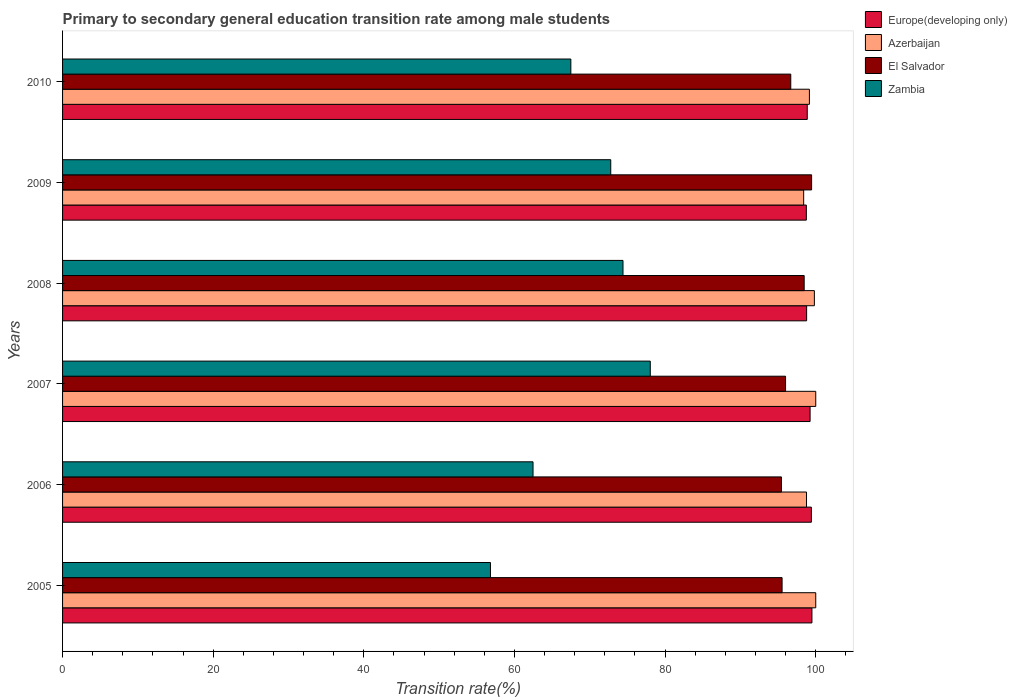How many different coloured bars are there?
Your answer should be compact. 4. How many groups of bars are there?
Provide a short and direct response. 6. Are the number of bars per tick equal to the number of legend labels?
Provide a succinct answer. Yes. Are the number of bars on each tick of the Y-axis equal?
Offer a terse response. Yes. How many bars are there on the 4th tick from the bottom?
Your answer should be very brief. 4. In how many cases, is the number of bars for a given year not equal to the number of legend labels?
Ensure brevity in your answer.  0. What is the transition rate in Europe(developing only) in 2008?
Offer a very short reply. 98.79. Across all years, what is the maximum transition rate in El Salvador?
Provide a short and direct response. 99.45. Across all years, what is the minimum transition rate in Zambia?
Offer a very short reply. 56.81. What is the total transition rate in El Salvador in the graph?
Ensure brevity in your answer.  581.56. What is the difference between the transition rate in Europe(developing only) in 2007 and that in 2010?
Keep it short and to the point. 0.38. What is the difference between the transition rate in Azerbaijan in 2006 and the transition rate in Zambia in 2008?
Provide a succinct answer. 24.37. What is the average transition rate in Europe(developing only) per year?
Make the answer very short. 99.09. In the year 2005, what is the difference between the transition rate in El Salvador and transition rate in Azerbaijan?
Offer a very short reply. -4.47. What is the ratio of the transition rate in Europe(developing only) in 2005 to that in 2007?
Offer a terse response. 1. What is the difference between the highest and the second highest transition rate in El Salvador?
Offer a very short reply. 0.99. What is the difference between the highest and the lowest transition rate in Azerbaijan?
Offer a very short reply. 1.6. In how many years, is the transition rate in El Salvador greater than the average transition rate in El Salvador taken over all years?
Your answer should be very brief. 2. Is the sum of the transition rate in Zambia in 2007 and 2009 greater than the maximum transition rate in Azerbaijan across all years?
Provide a short and direct response. Yes. What does the 3rd bar from the top in 2008 represents?
Offer a very short reply. Azerbaijan. What does the 2nd bar from the bottom in 2009 represents?
Provide a short and direct response. Azerbaijan. Is it the case that in every year, the sum of the transition rate in Zambia and transition rate in El Salvador is greater than the transition rate in Azerbaijan?
Offer a terse response. Yes. How many bars are there?
Ensure brevity in your answer.  24. Are all the bars in the graph horizontal?
Offer a very short reply. Yes. How many years are there in the graph?
Your answer should be compact. 6. How many legend labels are there?
Offer a very short reply. 4. What is the title of the graph?
Your response must be concise. Primary to secondary general education transition rate among male students. Does "Eritrea" appear as one of the legend labels in the graph?
Provide a short and direct response. No. What is the label or title of the X-axis?
Provide a succinct answer. Transition rate(%). What is the Transition rate(%) in Europe(developing only) in 2005?
Provide a succinct answer. 99.49. What is the Transition rate(%) in Azerbaijan in 2005?
Ensure brevity in your answer.  100. What is the Transition rate(%) in El Salvador in 2005?
Keep it short and to the point. 95.53. What is the Transition rate(%) in Zambia in 2005?
Offer a terse response. 56.81. What is the Transition rate(%) in Europe(developing only) in 2006?
Provide a succinct answer. 99.42. What is the Transition rate(%) in Azerbaijan in 2006?
Your response must be concise. 98.77. What is the Transition rate(%) in El Salvador in 2006?
Provide a short and direct response. 95.45. What is the Transition rate(%) of Zambia in 2006?
Give a very brief answer. 62.46. What is the Transition rate(%) in Europe(developing only) in 2007?
Give a very brief answer. 99.25. What is the Transition rate(%) in El Salvador in 2007?
Offer a very short reply. 95.99. What is the Transition rate(%) in Zambia in 2007?
Give a very brief answer. 78.03. What is the Transition rate(%) in Europe(developing only) in 2008?
Provide a succinct answer. 98.79. What is the Transition rate(%) in Azerbaijan in 2008?
Give a very brief answer. 99.82. What is the Transition rate(%) of El Salvador in 2008?
Ensure brevity in your answer.  98.46. What is the Transition rate(%) of Zambia in 2008?
Ensure brevity in your answer.  74.41. What is the Transition rate(%) of Europe(developing only) in 2009?
Provide a succinct answer. 98.75. What is the Transition rate(%) of Azerbaijan in 2009?
Provide a succinct answer. 98.4. What is the Transition rate(%) in El Salvador in 2009?
Make the answer very short. 99.45. What is the Transition rate(%) in Zambia in 2009?
Give a very brief answer. 72.78. What is the Transition rate(%) of Europe(developing only) in 2010?
Your response must be concise. 98.87. What is the Transition rate(%) in Azerbaijan in 2010?
Offer a very short reply. 99.16. What is the Transition rate(%) of El Salvador in 2010?
Your response must be concise. 96.68. What is the Transition rate(%) in Zambia in 2010?
Make the answer very short. 67.48. Across all years, what is the maximum Transition rate(%) of Europe(developing only)?
Provide a succinct answer. 99.49. Across all years, what is the maximum Transition rate(%) in Azerbaijan?
Keep it short and to the point. 100. Across all years, what is the maximum Transition rate(%) in El Salvador?
Give a very brief answer. 99.45. Across all years, what is the maximum Transition rate(%) in Zambia?
Ensure brevity in your answer.  78.03. Across all years, what is the minimum Transition rate(%) in Europe(developing only)?
Your response must be concise. 98.75. Across all years, what is the minimum Transition rate(%) of Azerbaijan?
Offer a very short reply. 98.4. Across all years, what is the minimum Transition rate(%) in El Salvador?
Offer a terse response. 95.45. Across all years, what is the minimum Transition rate(%) in Zambia?
Your response must be concise. 56.81. What is the total Transition rate(%) in Europe(developing only) in the graph?
Your answer should be very brief. 594.57. What is the total Transition rate(%) in Azerbaijan in the graph?
Provide a succinct answer. 596.14. What is the total Transition rate(%) of El Salvador in the graph?
Ensure brevity in your answer.  581.56. What is the total Transition rate(%) in Zambia in the graph?
Your answer should be compact. 411.98. What is the difference between the Transition rate(%) in Europe(developing only) in 2005 and that in 2006?
Keep it short and to the point. 0.08. What is the difference between the Transition rate(%) of Azerbaijan in 2005 and that in 2006?
Your response must be concise. 1.23. What is the difference between the Transition rate(%) of El Salvador in 2005 and that in 2006?
Make the answer very short. 0.08. What is the difference between the Transition rate(%) in Zambia in 2005 and that in 2006?
Offer a very short reply. -5.65. What is the difference between the Transition rate(%) of Europe(developing only) in 2005 and that in 2007?
Give a very brief answer. 0.24. What is the difference between the Transition rate(%) in El Salvador in 2005 and that in 2007?
Your answer should be very brief. -0.46. What is the difference between the Transition rate(%) in Zambia in 2005 and that in 2007?
Your response must be concise. -21.22. What is the difference between the Transition rate(%) in Europe(developing only) in 2005 and that in 2008?
Keep it short and to the point. 0.7. What is the difference between the Transition rate(%) in Azerbaijan in 2005 and that in 2008?
Offer a terse response. 0.18. What is the difference between the Transition rate(%) of El Salvador in 2005 and that in 2008?
Your answer should be very brief. -2.93. What is the difference between the Transition rate(%) in Zambia in 2005 and that in 2008?
Provide a short and direct response. -17.6. What is the difference between the Transition rate(%) of Europe(developing only) in 2005 and that in 2009?
Give a very brief answer. 0.74. What is the difference between the Transition rate(%) in Azerbaijan in 2005 and that in 2009?
Your response must be concise. 1.6. What is the difference between the Transition rate(%) in El Salvador in 2005 and that in 2009?
Offer a terse response. -3.92. What is the difference between the Transition rate(%) of Zambia in 2005 and that in 2009?
Your answer should be compact. -15.97. What is the difference between the Transition rate(%) in Europe(developing only) in 2005 and that in 2010?
Offer a terse response. 0.62. What is the difference between the Transition rate(%) of Azerbaijan in 2005 and that in 2010?
Give a very brief answer. 0.84. What is the difference between the Transition rate(%) in El Salvador in 2005 and that in 2010?
Your response must be concise. -1.15. What is the difference between the Transition rate(%) of Zambia in 2005 and that in 2010?
Your answer should be compact. -10.67. What is the difference between the Transition rate(%) in Europe(developing only) in 2006 and that in 2007?
Provide a short and direct response. 0.17. What is the difference between the Transition rate(%) in Azerbaijan in 2006 and that in 2007?
Make the answer very short. -1.23. What is the difference between the Transition rate(%) of El Salvador in 2006 and that in 2007?
Provide a succinct answer. -0.55. What is the difference between the Transition rate(%) in Zambia in 2006 and that in 2007?
Your answer should be compact. -15.57. What is the difference between the Transition rate(%) in Europe(developing only) in 2006 and that in 2008?
Offer a very short reply. 0.63. What is the difference between the Transition rate(%) of Azerbaijan in 2006 and that in 2008?
Offer a very short reply. -1.04. What is the difference between the Transition rate(%) in El Salvador in 2006 and that in 2008?
Offer a very short reply. -3.02. What is the difference between the Transition rate(%) in Zambia in 2006 and that in 2008?
Provide a succinct answer. -11.94. What is the difference between the Transition rate(%) of Europe(developing only) in 2006 and that in 2009?
Make the answer very short. 0.67. What is the difference between the Transition rate(%) in Azerbaijan in 2006 and that in 2009?
Your answer should be very brief. 0.38. What is the difference between the Transition rate(%) in El Salvador in 2006 and that in 2009?
Ensure brevity in your answer.  -4. What is the difference between the Transition rate(%) of Zambia in 2006 and that in 2009?
Your answer should be compact. -10.32. What is the difference between the Transition rate(%) in Europe(developing only) in 2006 and that in 2010?
Provide a short and direct response. 0.54. What is the difference between the Transition rate(%) in Azerbaijan in 2006 and that in 2010?
Ensure brevity in your answer.  -0.38. What is the difference between the Transition rate(%) in El Salvador in 2006 and that in 2010?
Provide a short and direct response. -1.24. What is the difference between the Transition rate(%) in Zambia in 2006 and that in 2010?
Provide a succinct answer. -5.02. What is the difference between the Transition rate(%) of Europe(developing only) in 2007 and that in 2008?
Offer a very short reply. 0.46. What is the difference between the Transition rate(%) in Azerbaijan in 2007 and that in 2008?
Offer a very short reply. 0.18. What is the difference between the Transition rate(%) in El Salvador in 2007 and that in 2008?
Provide a short and direct response. -2.47. What is the difference between the Transition rate(%) in Zambia in 2007 and that in 2008?
Offer a very short reply. 3.62. What is the difference between the Transition rate(%) of Europe(developing only) in 2007 and that in 2009?
Your answer should be compact. 0.5. What is the difference between the Transition rate(%) of Azerbaijan in 2007 and that in 2009?
Keep it short and to the point. 1.6. What is the difference between the Transition rate(%) of El Salvador in 2007 and that in 2009?
Your answer should be very brief. -3.46. What is the difference between the Transition rate(%) of Zambia in 2007 and that in 2009?
Give a very brief answer. 5.25. What is the difference between the Transition rate(%) in Europe(developing only) in 2007 and that in 2010?
Keep it short and to the point. 0.38. What is the difference between the Transition rate(%) of Azerbaijan in 2007 and that in 2010?
Offer a very short reply. 0.84. What is the difference between the Transition rate(%) of El Salvador in 2007 and that in 2010?
Keep it short and to the point. -0.69. What is the difference between the Transition rate(%) in Zambia in 2007 and that in 2010?
Offer a very short reply. 10.55. What is the difference between the Transition rate(%) of Europe(developing only) in 2008 and that in 2009?
Provide a succinct answer. 0.04. What is the difference between the Transition rate(%) of Azerbaijan in 2008 and that in 2009?
Keep it short and to the point. 1.42. What is the difference between the Transition rate(%) of El Salvador in 2008 and that in 2009?
Your answer should be compact. -0.99. What is the difference between the Transition rate(%) of Zambia in 2008 and that in 2009?
Provide a succinct answer. 1.63. What is the difference between the Transition rate(%) in Europe(developing only) in 2008 and that in 2010?
Offer a very short reply. -0.08. What is the difference between the Transition rate(%) in Azerbaijan in 2008 and that in 2010?
Provide a succinct answer. 0.66. What is the difference between the Transition rate(%) of El Salvador in 2008 and that in 2010?
Your answer should be very brief. 1.78. What is the difference between the Transition rate(%) of Zambia in 2008 and that in 2010?
Offer a very short reply. 6.92. What is the difference between the Transition rate(%) in Europe(developing only) in 2009 and that in 2010?
Your response must be concise. -0.12. What is the difference between the Transition rate(%) of Azerbaijan in 2009 and that in 2010?
Provide a short and direct response. -0.76. What is the difference between the Transition rate(%) of El Salvador in 2009 and that in 2010?
Your answer should be compact. 2.77. What is the difference between the Transition rate(%) of Zambia in 2009 and that in 2010?
Offer a terse response. 5.3. What is the difference between the Transition rate(%) of Europe(developing only) in 2005 and the Transition rate(%) of Azerbaijan in 2006?
Make the answer very short. 0.72. What is the difference between the Transition rate(%) in Europe(developing only) in 2005 and the Transition rate(%) in El Salvador in 2006?
Your answer should be very brief. 4.05. What is the difference between the Transition rate(%) of Europe(developing only) in 2005 and the Transition rate(%) of Zambia in 2006?
Your answer should be very brief. 37.03. What is the difference between the Transition rate(%) of Azerbaijan in 2005 and the Transition rate(%) of El Salvador in 2006?
Keep it short and to the point. 4.55. What is the difference between the Transition rate(%) in Azerbaijan in 2005 and the Transition rate(%) in Zambia in 2006?
Ensure brevity in your answer.  37.54. What is the difference between the Transition rate(%) of El Salvador in 2005 and the Transition rate(%) of Zambia in 2006?
Keep it short and to the point. 33.07. What is the difference between the Transition rate(%) of Europe(developing only) in 2005 and the Transition rate(%) of Azerbaijan in 2007?
Your answer should be very brief. -0.51. What is the difference between the Transition rate(%) in Europe(developing only) in 2005 and the Transition rate(%) in El Salvador in 2007?
Give a very brief answer. 3.5. What is the difference between the Transition rate(%) in Europe(developing only) in 2005 and the Transition rate(%) in Zambia in 2007?
Offer a terse response. 21.46. What is the difference between the Transition rate(%) in Azerbaijan in 2005 and the Transition rate(%) in El Salvador in 2007?
Your answer should be very brief. 4.01. What is the difference between the Transition rate(%) in Azerbaijan in 2005 and the Transition rate(%) in Zambia in 2007?
Your answer should be very brief. 21.97. What is the difference between the Transition rate(%) of El Salvador in 2005 and the Transition rate(%) of Zambia in 2007?
Provide a succinct answer. 17.5. What is the difference between the Transition rate(%) of Europe(developing only) in 2005 and the Transition rate(%) of Azerbaijan in 2008?
Your answer should be very brief. -0.33. What is the difference between the Transition rate(%) of Europe(developing only) in 2005 and the Transition rate(%) of El Salvador in 2008?
Provide a short and direct response. 1.03. What is the difference between the Transition rate(%) in Europe(developing only) in 2005 and the Transition rate(%) in Zambia in 2008?
Your response must be concise. 25.09. What is the difference between the Transition rate(%) of Azerbaijan in 2005 and the Transition rate(%) of El Salvador in 2008?
Provide a succinct answer. 1.54. What is the difference between the Transition rate(%) in Azerbaijan in 2005 and the Transition rate(%) in Zambia in 2008?
Make the answer very short. 25.59. What is the difference between the Transition rate(%) of El Salvador in 2005 and the Transition rate(%) of Zambia in 2008?
Your answer should be compact. 21.12. What is the difference between the Transition rate(%) in Europe(developing only) in 2005 and the Transition rate(%) in Azerbaijan in 2009?
Ensure brevity in your answer.  1.1. What is the difference between the Transition rate(%) in Europe(developing only) in 2005 and the Transition rate(%) in El Salvador in 2009?
Offer a terse response. 0.04. What is the difference between the Transition rate(%) in Europe(developing only) in 2005 and the Transition rate(%) in Zambia in 2009?
Make the answer very short. 26.71. What is the difference between the Transition rate(%) of Azerbaijan in 2005 and the Transition rate(%) of El Salvador in 2009?
Keep it short and to the point. 0.55. What is the difference between the Transition rate(%) of Azerbaijan in 2005 and the Transition rate(%) of Zambia in 2009?
Ensure brevity in your answer.  27.22. What is the difference between the Transition rate(%) in El Salvador in 2005 and the Transition rate(%) in Zambia in 2009?
Give a very brief answer. 22.75. What is the difference between the Transition rate(%) in Europe(developing only) in 2005 and the Transition rate(%) in Azerbaijan in 2010?
Give a very brief answer. 0.34. What is the difference between the Transition rate(%) of Europe(developing only) in 2005 and the Transition rate(%) of El Salvador in 2010?
Your answer should be compact. 2.81. What is the difference between the Transition rate(%) in Europe(developing only) in 2005 and the Transition rate(%) in Zambia in 2010?
Your answer should be compact. 32.01. What is the difference between the Transition rate(%) of Azerbaijan in 2005 and the Transition rate(%) of El Salvador in 2010?
Ensure brevity in your answer.  3.32. What is the difference between the Transition rate(%) of Azerbaijan in 2005 and the Transition rate(%) of Zambia in 2010?
Make the answer very short. 32.52. What is the difference between the Transition rate(%) in El Salvador in 2005 and the Transition rate(%) in Zambia in 2010?
Your answer should be very brief. 28.04. What is the difference between the Transition rate(%) of Europe(developing only) in 2006 and the Transition rate(%) of Azerbaijan in 2007?
Provide a succinct answer. -0.58. What is the difference between the Transition rate(%) of Europe(developing only) in 2006 and the Transition rate(%) of El Salvador in 2007?
Provide a short and direct response. 3.43. What is the difference between the Transition rate(%) in Europe(developing only) in 2006 and the Transition rate(%) in Zambia in 2007?
Offer a very short reply. 21.39. What is the difference between the Transition rate(%) of Azerbaijan in 2006 and the Transition rate(%) of El Salvador in 2007?
Keep it short and to the point. 2.78. What is the difference between the Transition rate(%) of Azerbaijan in 2006 and the Transition rate(%) of Zambia in 2007?
Offer a very short reply. 20.74. What is the difference between the Transition rate(%) of El Salvador in 2006 and the Transition rate(%) of Zambia in 2007?
Give a very brief answer. 17.42. What is the difference between the Transition rate(%) in Europe(developing only) in 2006 and the Transition rate(%) in Azerbaijan in 2008?
Make the answer very short. -0.4. What is the difference between the Transition rate(%) of Europe(developing only) in 2006 and the Transition rate(%) of El Salvador in 2008?
Ensure brevity in your answer.  0.96. What is the difference between the Transition rate(%) in Europe(developing only) in 2006 and the Transition rate(%) in Zambia in 2008?
Offer a very short reply. 25.01. What is the difference between the Transition rate(%) in Azerbaijan in 2006 and the Transition rate(%) in El Salvador in 2008?
Keep it short and to the point. 0.31. What is the difference between the Transition rate(%) of Azerbaijan in 2006 and the Transition rate(%) of Zambia in 2008?
Your answer should be very brief. 24.37. What is the difference between the Transition rate(%) of El Salvador in 2006 and the Transition rate(%) of Zambia in 2008?
Make the answer very short. 21.04. What is the difference between the Transition rate(%) in Europe(developing only) in 2006 and the Transition rate(%) in Azerbaijan in 2009?
Offer a very short reply. 1.02. What is the difference between the Transition rate(%) in Europe(developing only) in 2006 and the Transition rate(%) in El Salvador in 2009?
Provide a short and direct response. -0.03. What is the difference between the Transition rate(%) in Europe(developing only) in 2006 and the Transition rate(%) in Zambia in 2009?
Give a very brief answer. 26.64. What is the difference between the Transition rate(%) of Azerbaijan in 2006 and the Transition rate(%) of El Salvador in 2009?
Your answer should be compact. -0.68. What is the difference between the Transition rate(%) in Azerbaijan in 2006 and the Transition rate(%) in Zambia in 2009?
Provide a succinct answer. 25.99. What is the difference between the Transition rate(%) of El Salvador in 2006 and the Transition rate(%) of Zambia in 2009?
Your answer should be compact. 22.66. What is the difference between the Transition rate(%) of Europe(developing only) in 2006 and the Transition rate(%) of Azerbaijan in 2010?
Make the answer very short. 0.26. What is the difference between the Transition rate(%) in Europe(developing only) in 2006 and the Transition rate(%) in El Salvador in 2010?
Make the answer very short. 2.73. What is the difference between the Transition rate(%) of Europe(developing only) in 2006 and the Transition rate(%) of Zambia in 2010?
Make the answer very short. 31.93. What is the difference between the Transition rate(%) of Azerbaijan in 2006 and the Transition rate(%) of El Salvador in 2010?
Keep it short and to the point. 2.09. What is the difference between the Transition rate(%) in Azerbaijan in 2006 and the Transition rate(%) in Zambia in 2010?
Offer a terse response. 31.29. What is the difference between the Transition rate(%) of El Salvador in 2006 and the Transition rate(%) of Zambia in 2010?
Offer a very short reply. 27.96. What is the difference between the Transition rate(%) in Europe(developing only) in 2007 and the Transition rate(%) in Azerbaijan in 2008?
Keep it short and to the point. -0.57. What is the difference between the Transition rate(%) in Europe(developing only) in 2007 and the Transition rate(%) in El Salvador in 2008?
Provide a short and direct response. 0.79. What is the difference between the Transition rate(%) in Europe(developing only) in 2007 and the Transition rate(%) in Zambia in 2008?
Your response must be concise. 24.84. What is the difference between the Transition rate(%) in Azerbaijan in 2007 and the Transition rate(%) in El Salvador in 2008?
Your response must be concise. 1.54. What is the difference between the Transition rate(%) in Azerbaijan in 2007 and the Transition rate(%) in Zambia in 2008?
Offer a very short reply. 25.59. What is the difference between the Transition rate(%) in El Salvador in 2007 and the Transition rate(%) in Zambia in 2008?
Offer a very short reply. 21.58. What is the difference between the Transition rate(%) in Europe(developing only) in 2007 and the Transition rate(%) in Azerbaijan in 2009?
Provide a succinct answer. 0.85. What is the difference between the Transition rate(%) of Europe(developing only) in 2007 and the Transition rate(%) of El Salvador in 2009?
Ensure brevity in your answer.  -0.2. What is the difference between the Transition rate(%) of Europe(developing only) in 2007 and the Transition rate(%) of Zambia in 2009?
Keep it short and to the point. 26.47. What is the difference between the Transition rate(%) of Azerbaijan in 2007 and the Transition rate(%) of El Salvador in 2009?
Keep it short and to the point. 0.55. What is the difference between the Transition rate(%) of Azerbaijan in 2007 and the Transition rate(%) of Zambia in 2009?
Provide a short and direct response. 27.22. What is the difference between the Transition rate(%) of El Salvador in 2007 and the Transition rate(%) of Zambia in 2009?
Make the answer very short. 23.21. What is the difference between the Transition rate(%) in Europe(developing only) in 2007 and the Transition rate(%) in Azerbaijan in 2010?
Offer a terse response. 0.09. What is the difference between the Transition rate(%) of Europe(developing only) in 2007 and the Transition rate(%) of El Salvador in 2010?
Keep it short and to the point. 2.57. What is the difference between the Transition rate(%) in Europe(developing only) in 2007 and the Transition rate(%) in Zambia in 2010?
Your answer should be compact. 31.76. What is the difference between the Transition rate(%) in Azerbaijan in 2007 and the Transition rate(%) in El Salvador in 2010?
Make the answer very short. 3.32. What is the difference between the Transition rate(%) of Azerbaijan in 2007 and the Transition rate(%) of Zambia in 2010?
Offer a terse response. 32.52. What is the difference between the Transition rate(%) of El Salvador in 2007 and the Transition rate(%) of Zambia in 2010?
Provide a short and direct response. 28.51. What is the difference between the Transition rate(%) of Europe(developing only) in 2008 and the Transition rate(%) of Azerbaijan in 2009?
Keep it short and to the point. 0.39. What is the difference between the Transition rate(%) in Europe(developing only) in 2008 and the Transition rate(%) in El Salvador in 2009?
Your answer should be compact. -0.66. What is the difference between the Transition rate(%) in Europe(developing only) in 2008 and the Transition rate(%) in Zambia in 2009?
Offer a terse response. 26.01. What is the difference between the Transition rate(%) of Azerbaijan in 2008 and the Transition rate(%) of El Salvador in 2009?
Your answer should be compact. 0.37. What is the difference between the Transition rate(%) of Azerbaijan in 2008 and the Transition rate(%) of Zambia in 2009?
Provide a short and direct response. 27.04. What is the difference between the Transition rate(%) of El Salvador in 2008 and the Transition rate(%) of Zambia in 2009?
Your answer should be very brief. 25.68. What is the difference between the Transition rate(%) in Europe(developing only) in 2008 and the Transition rate(%) in Azerbaijan in 2010?
Your answer should be very brief. -0.37. What is the difference between the Transition rate(%) of Europe(developing only) in 2008 and the Transition rate(%) of El Salvador in 2010?
Keep it short and to the point. 2.11. What is the difference between the Transition rate(%) of Europe(developing only) in 2008 and the Transition rate(%) of Zambia in 2010?
Your answer should be compact. 31.3. What is the difference between the Transition rate(%) of Azerbaijan in 2008 and the Transition rate(%) of El Salvador in 2010?
Your response must be concise. 3.14. What is the difference between the Transition rate(%) in Azerbaijan in 2008 and the Transition rate(%) in Zambia in 2010?
Ensure brevity in your answer.  32.33. What is the difference between the Transition rate(%) of El Salvador in 2008 and the Transition rate(%) of Zambia in 2010?
Provide a short and direct response. 30.98. What is the difference between the Transition rate(%) in Europe(developing only) in 2009 and the Transition rate(%) in Azerbaijan in 2010?
Your answer should be very brief. -0.41. What is the difference between the Transition rate(%) of Europe(developing only) in 2009 and the Transition rate(%) of El Salvador in 2010?
Offer a terse response. 2.07. What is the difference between the Transition rate(%) of Europe(developing only) in 2009 and the Transition rate(%) of Zambia in 2010?
Offer a terse response. 31.27. What is the difference between the Transition rate(%) in Azerbaijan in 2009 and the Transition rate(%) in El Salvador in 2010?
Make the answer very short. 1.71. What is the difference between the Transition rate(%) of Azerbaijan in 2009 and the Transition rate(%) of Zambia in 2010?
Keep it short and to the point. 30.91. What is the difference between the Transition rate(%) in El Salvador in 2009 and the Transition rate(%) in Zambia in 2010?
Keep it short and to the point. 31.97. What is the average Transition rate(%) in Europe(developing only) per year?
Give a very brief answer. 99.09. What is the average Transition rate(%) in Azerbaijan per year?
Your response must be concise. 99.36. What is the average Transition rate(%) in El Salvador per year?
Offer a terse response. 96.93. What is the average Transition rate(%) in Zambia per year?
Give a very brief answer. 68.66. In the year 2005, what is the difference between the Transition rate(%) of Europe(developing only) and Transition rate(%) of Azerbaijan?
Make the answer very short. -0.51. In the year 2005, what is the difference between the Transition rate(%) of Europe(developing only) and Transition rate(%) of El Salvador?
Give a very brief answer. 3.96. In the year 2005, what is the difference between the Transition rate(%) of Europe(developing only) and Transition rate(%) of Zambia?
Give a very brief answer. 42.68. In the year 2005, what is the difference between the Transition rate(%) of Azerbaijan and Transition rate(%) of El Salvador?
Provide a short and direct response. 4.47. In the year 2005, what is the difference between the Transition rate(%) of Azerbaijan and Transition rate(%) of Zambia?
Offer a terse response. 43.19. In the year 2005, what is the difference between the Transition rate(%) of El Salvador and Transition rate(%) of Zambia?
Ensure brevity in your answer.  38.72. In the year 2006, what is the difference between the Transition rate(%) of Europe(developing only) and Transition rate(%) of Azerbaijan?
Provide a succinct answer. 0.64. In the year 2006, what is the difference between the Transition rate(%) of Europe(developing only) and Transition rate(%) of El Salvador?
Your answer should be very brief. 3.97. In the year 2006, what is the difference between the Transition rate(%) in Europe(developing only) and Transition rate(%) in Zambia?
Give a very brief answer. 36.95. In the year 2006, what is the difference between the Transition rate(%) in Azerbaijan and Transition rate(%) in El Salvador?
Offer a very short reply. 3.33. In the year 2006, what is the difference between the Transition rate(%) in Azerbaijan and Transition rate(%) in Zambia?
Your response must be concise. 36.31. In the year 2006, what is the difference between the Transition rate(%) in El Salvador and Transition rate(%) in Zambia?
Ensure brevity in your answer.  32.98. In the year 2007, what is the difference between the Transition rate(%) in Europe(developing only) and Transition rate(%) in Azerbaijan?
Offer a terse response. -0.75. In the year 2007, what is the difference between the Transition rate(%) in Europe(developing only) and Transition rate(%) in El Salvador?
Give a very brief answer. 3.26. In the year 2007, what is the difference between the Transition rate(%) in Europe(developing only) and Transition rate(%) in Zambia?
Ensure brevity in your answer.  21.22. In the year 2007, what is the difference between the Transition rate(%) of Azerbaijan and Transition rate(%) of El Salvador?
Your response must be concise. 4.01. In the year 2007, what is the difference between the Transition rate(%) in Azerbaijan and Transition rate(%) in Zambia?
Your answer should be compact. 21.97. In the year 2007, what is the difference between the Transition rate(%) of El Salvador and Transition rate(%) of Zambia?
Give a very brief answer. 17.96. In the year 2008, what is the difference between the Transition rate(%) in Europe(developing only) and Transition rate(%) in Azerbaijan?
Your answer should be compact. -1.03. In the year 2008, what is the difference between the Transition rate(%) of Europe(developing only) and Transition rate(%) of El Salvador?
Offer a very short reply. 0.33. In the year 2008, what is the difference between the Transition rate(%) in Europe(developing only) and Transition rate(%) in Zambia?
Make the answer very short. 24.38. In the year 2008, what is the difference between the Transition rate(%) in Azerbaijan and Transition rate(%) in El Salvador?
Your answer should be very brief. 1.36. In the year 2008, what is the difference between the Transition rate(%) in Azerbaijan and Transition rate(%) in Zambia?
Provide a succinct answer. 25.41. In the year 2008, what is the difference between the Transition rate(%) of El Salvador and Transition rate(%) of Zambia?
Provide a succinct answer. 24.05. In the year 2009, what is the difference between the Transition rate(%) in Europe(developing only) and Transition rate(%) in Azerbaijan?
Provide a short and direct response. 0.35. In the year 2009, what is the difference between the Transition rate(%) in Europe(developing only) and Transition rate(%) in El Salvador?
Keep it short and to the point. -0.7. In the year 2009, what is the difference between the Transition rate(%) in Europe(developing only) and Transition rate(%) in Zambia?
Provide a short and direct response. 25.97. In the year 2009, what is the difference between the Transition rate(%) in Azerbaijan and Transition rate(%) in El Salvador?
Your response must be concise. -1.06. In the year 2009, what is the difference between the Transition rate(%) in Azerbaijan and Transition rate(%) in Zambia?
Keep it short and to the point. 25.61. In the year 2009, what is the difference between the Transition rate(%) of El Salvador and Transition rate(%) of Zambia?
Your answer should be compact. 26.67. In the year 2010, what is the difference between the Transition rate(%) in Europe(developing only) and Transition rate(%) in Azerbaijan?
Ensure brevity in your answer.  -0.29. In the year 2010, what is the difference between the Transition rate(%) of Europe(developing only) and Transition rate(%) of El Salvador?
Keep it short and to the point. 2.19. In the year 2010, what is the difference between the Transition rate(%) in Europe(developing only) and Transition rate(%) in Zambia?
Keep it short and to the point. 31.39. In the year 2010, what is the difference between the Transition rate(%) in Azerbaijan and Transition rate(%) in El Salvador?
Keep it short and to the point. 2.48. In the year 2010, what is the difference between the Transition rate(%) of Azerbaijan and Transition rate(%) of Zambia?
Provide a succinct answer. 31.67. In the year 2010, what is the difference between the Transition rate(%) of El Salvador and Transition rate(%) of Zambia?
Ensure brevity in your answer.  29.2. What is the ratio of the Transition rate(%) of Europe(developing only) in 2005 to that in 2006?
Offer a terse response. 1. What is the ratio of the Transition rate(%) in Azerbaijan in 2005 to that in 2006?
Give a very brief answer. 1.01. What is the ratio of the Transition rate(%) of El Salvador in 2005 to that in 2006?
Your answer should be compact. 1. What is the ratio of the Transition rate(%) in Zambia in 2005 to that in 2006?
Provide a succinct answer. 0.91. What is the ratio of the Transition rate(%) of Azerbaijan in 2005 to that in 2007?
Give a very brief answer. 1. What is the ratio of the Transition rate(%) of El Salvador in 2005 to that in 2007?
Offer a very short reply. 1. What is the ratio of the Transition rate(%) of Zambia in 2005 to that in 2007?
Offer a terse response. 0.73. What is the ratio of the Transition rate(%) of Europe(developing only) in 2005 to that in 2008?
Your answer should be compact. 1.01. What is the ratio of the Transition rate(%) of El Salvador in 2005 to that in 2008?
Provide a succinct answer. 0.97. What is the ratio of the Transition rate(%) of Zambia in 2005 to that in 2008?
Your answer should be compact. 0.76. What is the ratio of the Transition rate(%) in Europe(developing only) in 2005 to that in 2009?
Provide a short and direct response. 1.01. What is the ratio of the Transition rate(%) in Azerbaijan in 2005 to that in 2009?
Offer a very short reply. 1.02. What is the ratio of the Transition rate(%) of El Salvador in 2005 to that in 2009?
Give a very brief answer. 0.96. What is the ratio of the Transition rate(%) of Zambia in 2005 to that in 2009?
Your answer should be very brief. 0.78. What is the ratio of the Transition rate(%) in Azerbaijan in 2005 to that in 2010?
Provide a short and direct response. 1.01. What is the ratio of the Transition rate(%) of Zambia in 2005 to that in 2010?
Give a very brief answer. 0.84. What is the ratio of the Transition rate(%) of Zambia in 2006 to that in 2007?
Make the answer very short. 0.8. What is the ratio of the Transition rate(%) in Europe(developing only) in 2006 to that in 2008?
Your answer should be compact. 1.01. What is the ratio of the Transition rate(%) in Azerbaijan in 2006 to that in 2008?
Ensure brevity in your answer.  0.99. What is the ratio of the Transition rate(%) in El Salvador in 2006 to that in 2008?
Ensure brevity in your answer.  0.97. What is the ratio of the Transition rate(%) of Zambia in 2006 to that in 2008?
Provide a short and direct response. 0.84. What is the ratio of the Transition rate(%) of Europe(developing only) in 2006 to that in 2009?
Keep it short and to the point. 1.01. What is the ratio of the Transition rate(%) in El Salvador in 2006 to that in 2009?
Make the answer very short. 0.96. What is the ratio of the Transition rate(%) in Zambia in 2006 to that in 2009?
Your answer should be very brief. 0.86. What is the ratio of the Transition rate(%) of El Salvador in 2006 to that in 2010?
Your answer should be very brief. 0.99. What is the ratio of the Transition rate(%) of Zambia in 2006 to that in 2010?
Give a very brief answer. 0.93. What is the ratio of the Transition rate(%) in El Salvador in 2007 to that in 2008?
Keep it short and to the point. 0.97. What is the ratio of the Transition rate(%) of Zambia in 2007 to that in 2008?
Offer a terse response. 1.05. What is the ratio of the Transition rate(%) in Azerbaijan in 2007 to that in 2009?
Offer a very short reply. 1.02. What is the ratio of the Transition rate(%) of El Salvador in 2007 to that in 2009?
Provide a short and direct response. 0.97. What is the ratio of the Transition rate(%) in Zambia in 2007 to that in 2009?
Provide a succinct answer. 1.07. What is the ratio of the Transition rate(%) in Azerbaijan in 2007 to that in 2010?
Ensure brevity in your answer.  1.01. What is the ratio of the Transition rate(%) in Zambia in 2007 to that in 2010?
Give a very brief answer. 1.16. What is the ratio of the Transition rate(%) in Azerbaijan in 2008 to that in 2009?
Provide a succinct answer. 1.01. What is the ratio of the Transition rate(%) of El Salvador in 2008 to that in 2009?
Give a very brief answer. 0.99. What is the ratio of the Transition rate(%) in Zambia in 2008 to that in 2009?
Your response must be concise. 1.02. What is the ratio of the Transition rate(%) in El Salvador in 2008 to that in 2010?
Give a very brief answer. 1.02. What is the ratio of the Transition rate(%) in Zambia in 2008 to that in 2010?
Provide a succinct answer. 1.1. What is the ratio of the Transition rate(%) in Europe(developing only) in 2009 to that in 2010?
Offer a terse response. 1. What is the ratio of the Transition rate(%) of Azerbaijan in 2009 to that in 2010?
Offer a very short reply. 0.99. What is the ratio of the Transition rate(%) of El Salvador in 2009 to that in 2010?
Give a very brief answer. 1.03. What is the ratio of the Transition rate(%) of Zambia in 2009 to that in 2010?
Offer a terse response. 1.08. What is the difference between the highest and the second highest Transition rate(%) of Europe(developing only)?
Give a very brief answer. 0.08. What is the difference between the highest and the second highest Transition rate(%) of El Salvador?
Make the answer very short. 0.99. What is the difference between the highest and the second highest Transition rate(%) of Zambia?
Offer a terse response. 3.62. What is the difference between the highest and the lowest Transition rate(%) in Europe(developing only)?
Provide a succinct answer. 0.74. What is the difference between the highest and the lowest Transition rate(%) in Azerbaijan?
Your answer should be compact. 1.6. What is the difference between the highest and the lowest Transition rate(%) of El Salvador?
Offer a terse response. 4. What is the difference between the highest and the lowest Transition rate(%) of Zambia?
Keep it short and to the point. 21.22. 